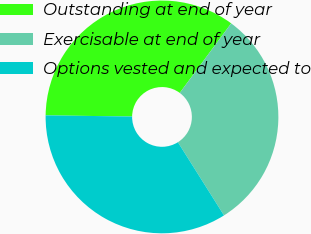Convert chart. <chart><loc_0><loc_0><loc_500><loc_500><pie_chart><fcel>Outstanding at end of year<fcel>Exercisable at end of year<fcel>Options vested and expected to<nl><fcel>34.92%<fcel>30.92%<fcel>34.16%<nl></chart> 